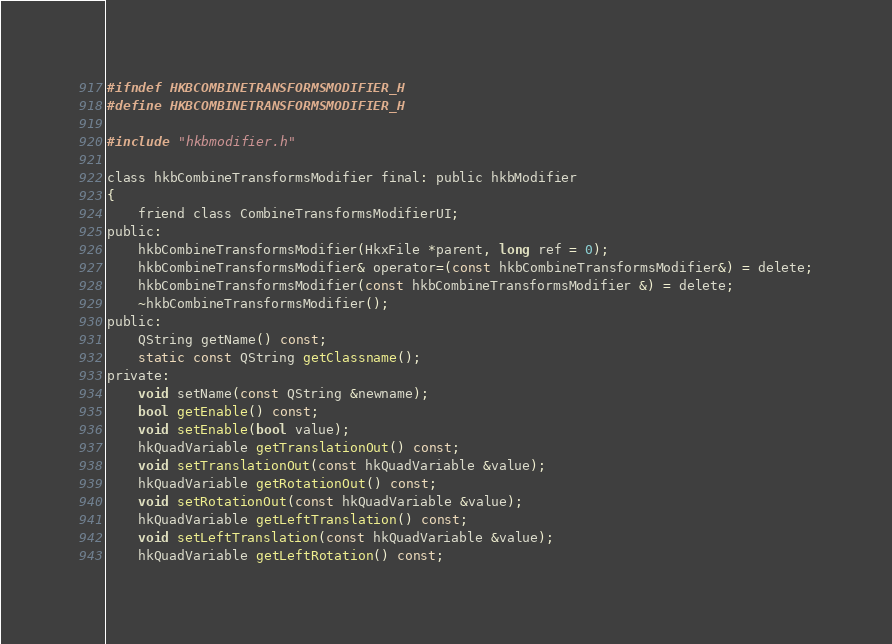Convert code to text. <code><loc_0><loc_0><loc_500><loc_500><_C_>#ifndef HKBCOMBINETRANSFORMSMODIFIER_H
#define HKBCOMBINETRANSFORMSMODIFIER_H

#include "hkbmodifier.h"

class hkbCombineTransformsModifier final: public hkbModifier
{
    friend class CombineTransformsModifierUI;
public:
    hkbCombineTransformsModifier(HkxFile *parent, long ref = 0);
    hkbCombineTransformsModifier& operator=(const hkbCombineTransformsModifier&) = delete;
    hkbCombineTransformsModifier(const hkbCombineTransformsModifier &) = delete;
    ~hkbCombineTransformsModifier();
public:
    QString getName() const;
    static const QString getClassname();
private:
    void setName(const QString &newname);
    bool getEnable() const;
    void setEnable(bool value);
    hkQuadVariable getTranslationOut() const;
    void setTranslationOut(const hkQuadVariable &value);
    hkQuadVariable getRotationOut() const;
    void setRotationOut(const hkQuadVariable &value);
    hkQuadVariable getLeftTranslation() const;
    void setLeftTranslation(const hkQuadVariable &value);
    hkQuadVariable getLeftRotation() const;</code> 